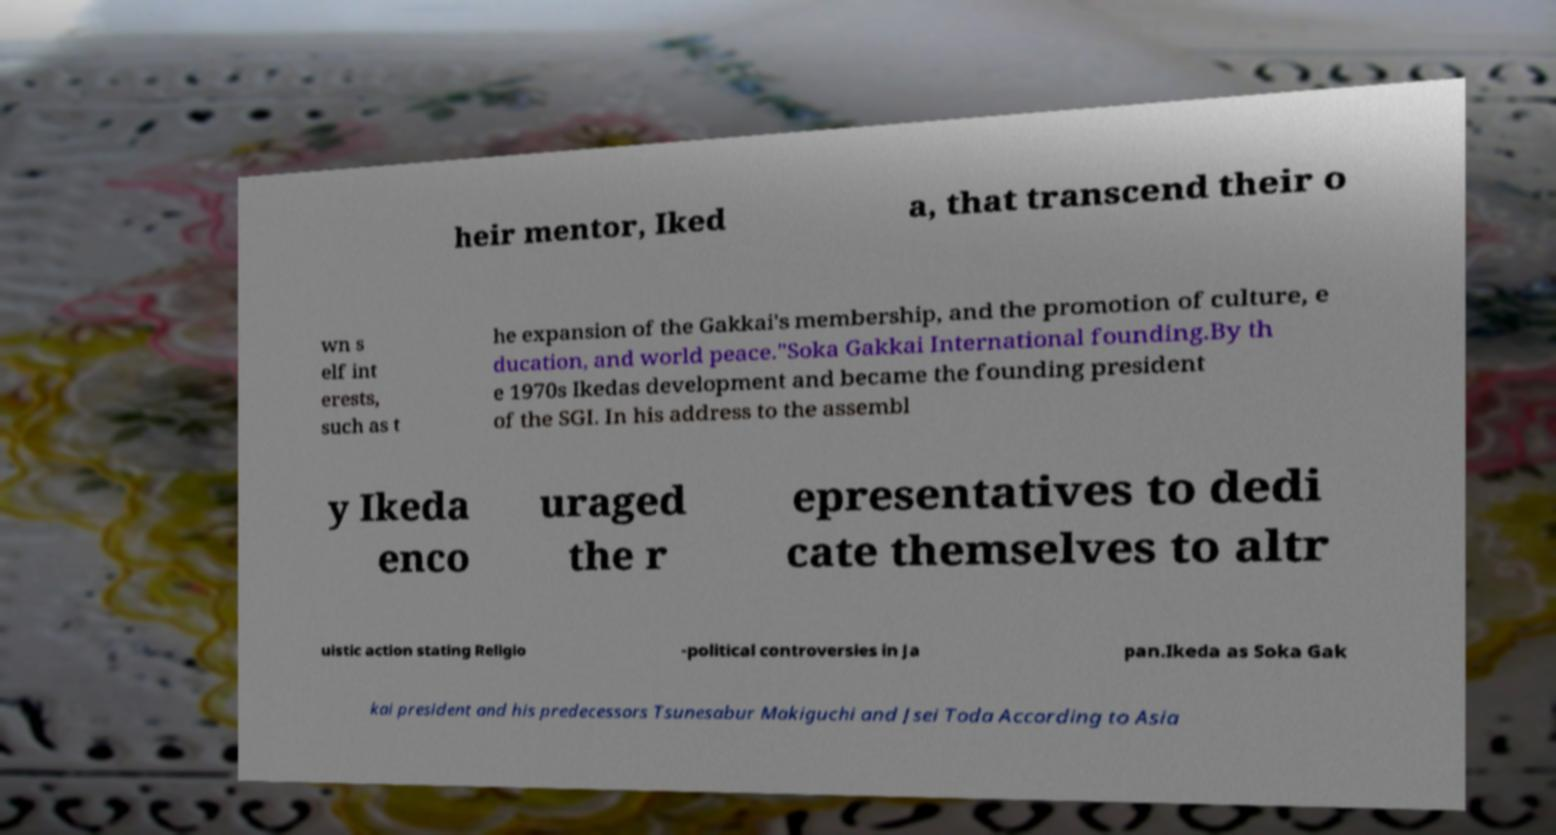Please identify and transcribe the text found in this image. heir mentor, Iked a, that transcend their o wn s elf int erests, such as t he expansion of the Gakkai's membership, and the promotion of culture, e ducation, and world peace."Soka Gakkai International founding.By th e 1970s Ikedas development and became the founding president of the SGI. In his address to the assembl y Ikeda enco uraged the r epresentatives to dedi cate themselves to altr uistic action stating Religio -political controversies in Ja pan.Ikeda as Soka Gak kai president and his predecessors Tsunesabur Makiguchi and Jsei Toda According to Asia 